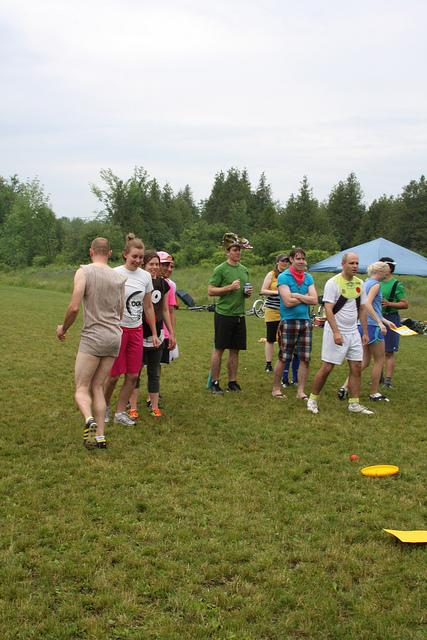Where are they playing a game? Please explain your reasoning. park. This is a wide grassy area. 